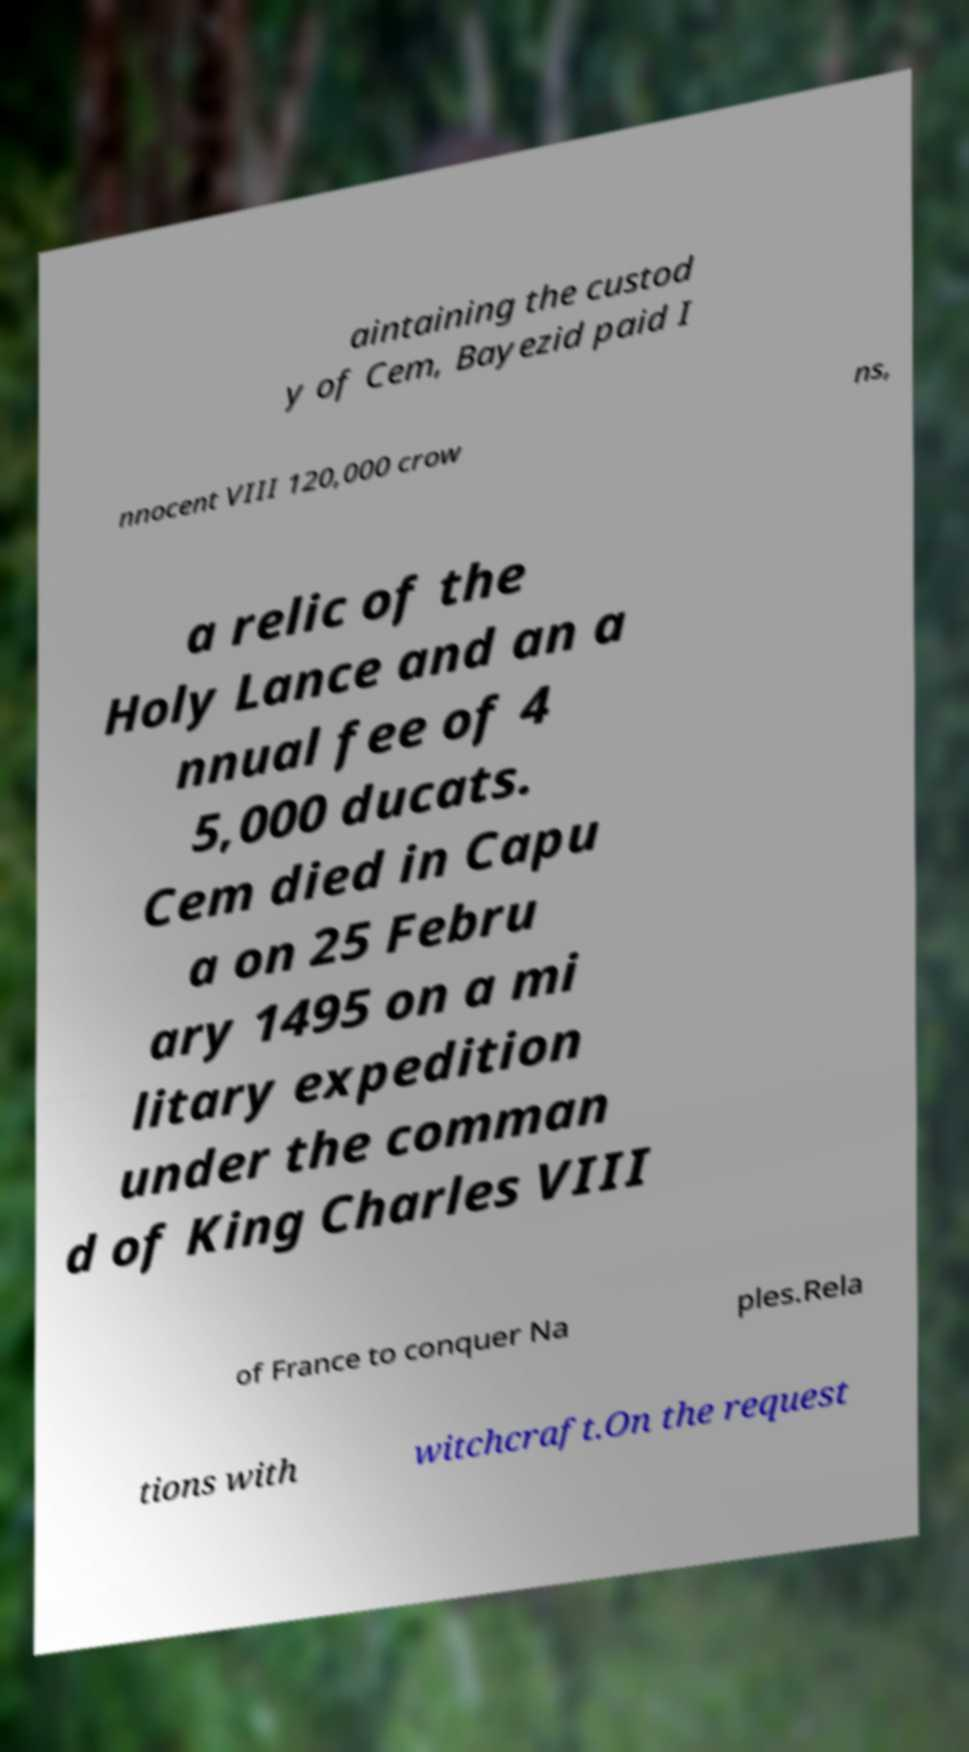Please identify and transcribe the text found in this image. aintaining the custod y of Cem, Bayezid paid I nnocent VIII 120,000 crow ns, a relic of the Holy Lance and an a nnual fee of 4 5,000 ducats. Cem died in Capu a on 25 Febru ary 1495 on a mi litary expedition under the comman d of King Charles VIII of France to conquer Na ples.Rela tions with witchcraft.On the request 